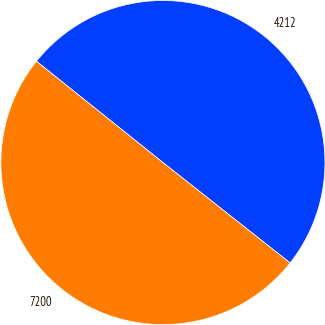Convert chart to OTSL. <chart><loc_0><loc_0><loc_500><loc_500><pie_chart><fcel>4212<fcel>7200<nl><fcel>49.89%<fcel>50.11%<nl></chart> 